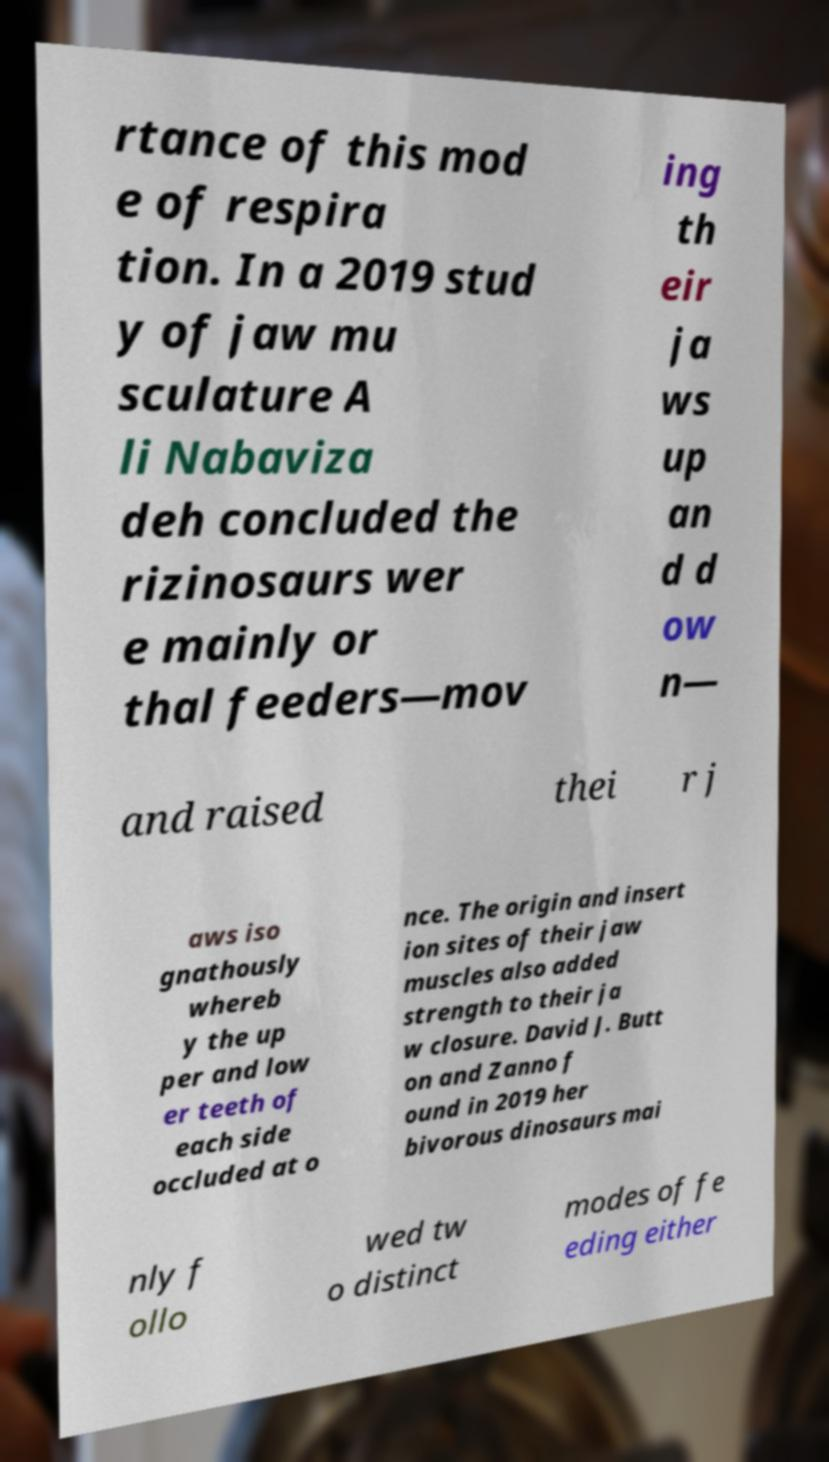For documentation purposes, I need the text within this image transcribed. Could you provide that? rtance of this mod e of respira tion. In a 2019 stud y of jaw mu sculature A li Nabaviza deh concluded the rizinosaurs wer e mainly or thal feeders—mov ing th eir ja ws up an d d ow n— and raised thei r j aws iso gnathously whereb y the up per and low er teeth of each side occluded at o nce. The origin and insert ion sites of their jaw muscles also added strength to their ja w closure. David J. Butt on and Zanno f ound in 2019 her bivorous dinosaurs mai nly f ollo wed tw o distinct modes of fe eding either 